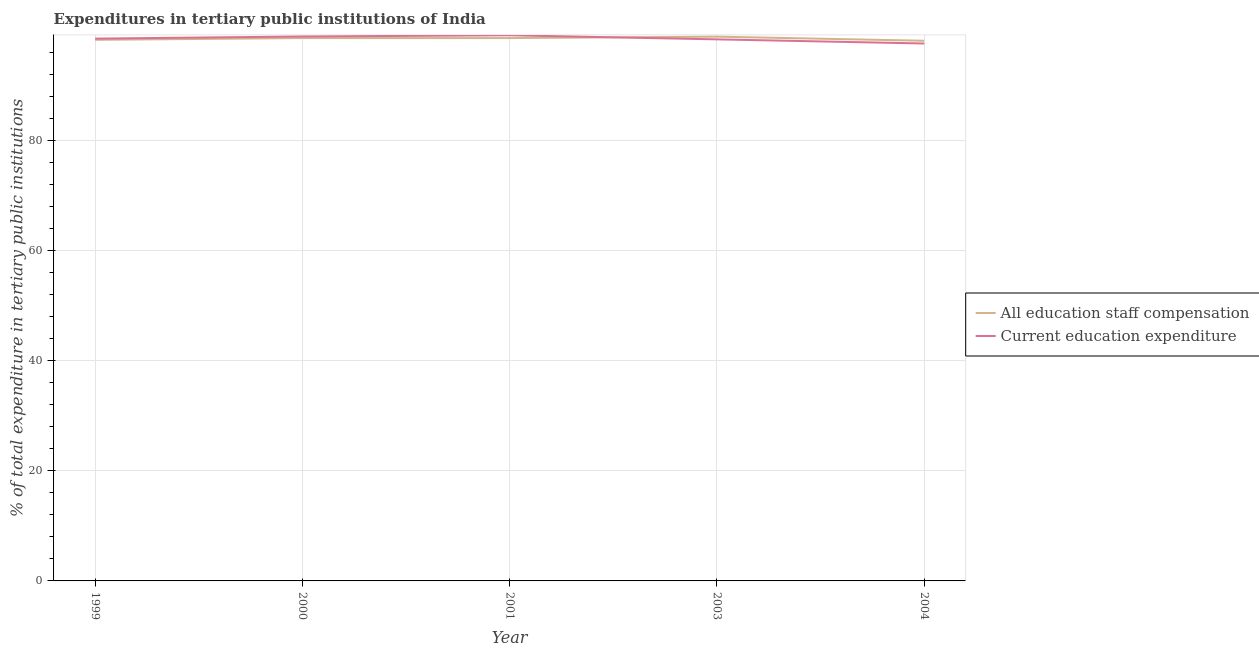Is the number of lines equal to the number of legend labels?
Offer a terse response. Yes. What is the expenditure in staff compensation in 1999?
Give a very brief answer. 98.21. Across all years, what is the maximum expenditure in staff compensation?
Provide a short and direct response. 98.79. Across all years, what is the minimum expenditure in education?
Give a very brief answer. 97.55. In which year was the expenditure in staff compensation maximum?
Provide a short and direct response. 2003. What is the total expenditure in education in the graph?
Make the answer very short. 492.13. What is the difference between the expenditure in staff compensation in 2001 and that in 2003?
Provide a short and direct response. -0.26. What is the difference between the expenditure in education in 1999 and the expenditure in staff compensation in 2003?
Offer a very short reply. -0.36. What is the average expenditure in staff compensation per year?
Give a very brief answer. 98.42. In the year 2004, what is the difference between the expenditure in education and expenditure in staff compensation?
Your response must be concise. -0.5. In how many years, is the expenditure in staff compensation greater than 40 %?
Offer a terse response. 5. What is the ratio of the expenditure in staff compensation in 1999 to that in 2001?
Keep it short and to the point. 1. Is the expenditure in education in 2003 less than that in 2004?
Keep it short and to the point. No. Is the difference between the expenditure in education in 1999 and 2004 greater than the difference between the expenditure in staff compensation in 1999 and 2004?
Keep it short and to the point. Yes. What is the difference between the highest and the second highest expenditure in staff compensation?
Provide a succinct answer. 0.26. What is the difference between the highest and the lowest expenditure in education?
Offer a terse response. 1.49. Does the expenditure in staff compensation monotonically increase over the years?
Make the answer very short. No. Is the expenditure in staff compensation strictly greater than the expenditure in education over the years?
Ensure brevity in your answer.  No. How many years are there in the graph?
Give a very brief answer. 5. What is the difference between two consecutive major ticks on the Y-axis?
Your answer should be compact. 20. Are the values on the major ticks of Y-axis written in scientific E-notation?
Your response must be concise. No. Does the graph contain any zero values?
Ensure brevity in your answer.  No. Does the graph contain grids?
Provide a short and direct response. Yes. Where does the legend appear in the graph?
Provide a succinct answer. Center right. How are the legend labels stacked?
Provide a succinct answer. Vertical. What is the title of the graph?
Your answer should be very brief. Expenditures in tertiary public institutions of India. What is the label or title of the X-axis?
Provide a short and direct response. Year. What is the label or title of the Y-axis?
Ensure brevity in your answer.  % of total expenditure in tertiary public institutions. What is the % of total expenditure in tertiary public institutions of All education staff compensation in 1999?
Provide a succinct answer. 98.21. What is the % of total expenditure in tertiary public institutions of Current education expenditure in 1999?
Provide a succinct answer. 98.43. What is the % of total expenditure in tertiary public institutions of All education staff compensation in 2000?
Provide a short and direct response. 98.53. What is the % of total expenditure in tertiary public institutions of Current education expenditure in 2000?
Make the answer very short. 98.82. What is the % of total expenditure in tertiary public institutions of All education staff compensation in 2001?
Your answer should be compact. 98.53. What is the % of total expenditure in tertiary public institutions of Current education expenditure in 2001?
Your response must be concise. 99.04. What is the % of total expenditure in tertiary public institutions of All education staff compensation in 2003?
Ensure brevity in your answer.  98.79. What is the % of total expenditure in tertiary public institutions in Current education expenditure in 2003?
Your answer should be very brief. 98.3. What is the % of total expenditure in tertiary public institutions of All education staff compensation in 2004?
Your response must be concise. 98.04. What is the % of total expenditure in tertiary public institutions of Current education expenditure in 2004?
Your answer should be compact. 97.55. Across all years, what is the maximum % of total expenditure in tertiary public institutions in All education staff compensation?
Offer a very short reply. 98.79. Across all years, what is the maximum % of total expenditure in tertiary public institutions of Current education expenditure?
Ensure brevity in your answer.  99.04. Across all years, what is the minimum % of total expenditure in tertiary public institutions in All education staff compensation?
Provide a succinct answer. 98.04. Across all years, what is the minimum % of total expenditure in tertiary public institutions of Current education expenditure?
Give a very brief answer. 97.55. What is the total % of total expenditure in tertiary public institutions of All education staff compensation in the graph?
Your response must be concise. 492.1. What is the total % of total expenditure in tertiary public institutions in Current education expenditure in the graph?
Keep it short and to the point. 492.13. What is the difference between the % of total expenditure in tertiary public institutions in All education staff compensation in 1999 and that in 2000?
Offer a very short reply. -0.32. What is the difference between the % of total expenditure in tertiary public institutions in Current education expenditure in 1999 and that in 2000?
Offer a very short reply. -0.39. What is the difference between the % of total expenditure in tertiary public institutions in All education staff compensation in 1999 and that in 2001?
Give a very brief answer. -0.32. What is the difference between the % of total expenditure in tertiary public institutions of Current education expenditure in 1999 and that in 2001?
Offer a terse response. -0.61. What is the difference between the % of total expenditure in tertiary public institutions in All education staff compensation in 1999 and that in 2003?
Offer a terse response. -0.58. What is the difference between the % of total expenditure in tertiary public institutions in Current education expenditure in 1999 and that in 2003?
Keep it short and to the point. 0.13. What is the difference between the % of total expenditure in tertiary public institutions in All education staff compensation in 1999 and that in 2004?
Offer a terse response. 0.17. What is the difference between the % of total expenditure in tertiary public institutions of Current education expenditure in 1999 and that in 2004?
Provide a short and direct response. 0.88. What is the difference between the % of total expenditure in tertiary public institutions of All education staff compensation in 2000 and that in 2001?
Keep it short and to the point. 0. What is the difference between the % of total expenditure in tertiary public institutions in Current education expenditure in 2000 and that in 2001?
Keep it short and to the point. -0.22. What is the difference between the % of total expenditure in tertiary public institutions of All education staff compensation in 2000 and that in 2003?
Your answer should be very brief. -0.26. What is the difference between the % of total expenditure in tertiary public institutions in Current education expenditure in 2000 and that in 2003?
Give a very brief answer. 0.52. What is the difference between the % of total expenditure in tertiary public institutions in All education staff compensation in 2000 and that in 2004?
Offer a terse response. 0.49. What is the difference between the % of total expenditure in tertiary public institutions in Current education expenditure in 2000 and that in 2004?
Your answer should be compact. 1.27. What is the difference between the % of total expenditure in tertiary public institutions of All education staff compensation in 2001 and that in 2003?
Offer a very short reply. -0.26. What is the difference between the % of total expenditure in tertiary public institutions of Current education expenditure in 2001 and that in 2003?
Offer a terse response. 0.74. What is the difference between the % of total expenditure in tertiary public institutions of All education staff compensation in 2001 and that in 2004?
Your answer should be compact. 0.49. What is the difference between the % of total expenditure in tertiary public institutions of Current education expenditure in 2001 and that in 2004?
Give a very brief answer. 1.49. What is the difference between the % of total expenditure in tertiary public institutions of All education staff compensation in 2003 and that in 2004?
Your response must be concise. 0.75. What is the difference between the % of total expenditure in tertiary public institutions of Current education expenditure in 2003 and that in 2004?
Offer a very short reply. 0.75. What is the difference between the % of total expenditure in tertiary public institutions of All education staff compensation in 1999 and the % of total expenditure in tertiary public institutions of Current education expenditure in 2000?
Your answer should be compact. -0.61. What is the difference between the % of total expenditure in tertiary public institutions in All education staff compensation in 1999 and the % of total expenditure in tertiary public institutions in Current education expenditure in 2001?
Give a very brief answer. -0.82. What is the difference between the % of total expenditure in tertiary public institutions in All education staff compensation in 1999 and the % of total expenditure in tertiary public institutions in Current education expenditure in 2003?
Your response must be concise. -0.08. What is the difference between the % of total expenditure in tertiary public institutions in All education staff compensation in 1999 and the % of total expenditure in tertiary public institutions in Current education expenditure in 2004?
Your answer should be very brief. 0.67. What is the difference between the % of total expenditure in tertiary public institutions in All education staff compensation in 2000 and the % of total expenditure in tertiary public institutions in Current education expenditure in 2001?
Your response must be concise. -0.51. What is the difference between the % of total expenditure in tertiary public institutions in All education staff compensation in 2000 and the % of total expenditure in tertiary public institutions in Current education expenditure in 2003?
Your response must be concise. 0.23. What is the difference between the % of total expenditure in tertiary public institutions of All education staff compensation in 2000 and the % of total expenditure in tertiary public institutions of Current education expenditure in 2004?
Your answer should be compact. 0.98. What is the difference between the % of total expenditure in tertiary public institutions in All education staff compensation in 2001 and the % of total expenditure in tertiary public institutions in Current education expenditure in 2003?
Provide a short and direct response. 0.23. What is the difference between the % of total expenditure in tertiary public institutions of All education staff compensation in 2001 and the % of total expenditure in tertiary public institutions of Current education expenditure in 2004?
Provide a short and direct response. 0.98. What is the difference between the % of total expenditure in tertiary public institutions of All education staff compensation in 2003 and the % of total expenditure in tertiary public institutions of Current education expenditure in 2004?
Your answer should be compact. 1.24. What is the average % of total expenditure in tertiary public institutions in All education staff compensation per year?
Ensure brevity in your answer.  98.42. What is the average % of total expenditure in tertiary public institutions of Current education expenditure per year?
Give a very brief answer. 98.43. In the year 1999, what is the difference between the % of total expenditure in tertiary public institutions of All education staff compensation and % of total expenditure in tertiary public institutions of Current education expenditure?
Offer a very short reply. -0.22. In the year 2000, what is the difference between the % of total expenditure in tertiary public institutions in All education staff compensation and % of total expenditure in tertiary public institutions in Current education expenditure?
Your answer should be compact. -0.29. In the year 2001, what is the difference between the % of total expenditure in tertiary public institutions in All education staff compensation and % of total expenditure in tertiary public institutions in Current education expenditure?
Provide a succinct answer. -0.51. In the year 2003, what is the difference between the % of total expenditure in tertiary public institutions in All education staff compensation and % of total expenditure in tertiary public institutions in Current education expenditure?
Your answer should be compact. 0.49. In the year 2004, what is the difference between the % of total expenditure in tertiary public institutions of All education staff compensation and % of total expenditure in tertiary public institutions of Current education expenditure?
Provide a succinct answer. 0.5. What is the ratio of the % of total expenditure in tertiary public institutions in Current education expenditure in 1999 to that in 2000?
Offer a terse response. 1. What is the ratio of the % of total expenditure in tertiary public institutions in All education staff compensation in 1999 to that in 2001?
Your response must be concise. 1. What is the ratio of the % of total expenditure in tertiary public institutions of Current education expenditure in 1999 to that in 2003?
Offer a very short reply. 1. What is the ratio of the % of total expenditure in tertiary public institutions in All education staff compensation in 1999 to that in 2004?
Ensure brevity in your answer.  1. What is the ratio of the % of total expenditure in tertiary public institutions of Current education expenditure in 1999 to that in 2004?
Make the answer very short. 1.01. What is the ratio of the % of total expenditure in tertiary public institutions of All education staff compensation in 2000 to that in 2001?
Ensure brevity in your answer.  1. What is the ratio of the % of total expenditure in tertiary public institutions of Current education expenditure in 2000 to that in 2001?
Your answer should be compact. 1. What is the ratio of the % of total expenditure in tertiary public institutions of All education staff compensation in 2000 to that in 2003?
Provide a succinct answer. 1. What is the ratio of the % of total expenditure in tertiary public institutions in All education staff compensation in 2000 to that in 2004?
Provide a short and direct response. 1. What is the ratio of the % of total expenditure in tertiary public institutions of Current education expenditure in 2000 to that in 2004?
Provide a succinct answer. 1.01. What is the ratio of the % of total expenditure in tertiary public institutions in Current education expenditure in 2001 to that in 2003?
Your answer should be compact. 1.01. What is the ratio of the % of total expenditure in tertiary public institutions in Current education expenditure in 2001 to that in 2004?
Provide a succinct answer. 1.02. What is the ratio of the % of total expenditure in tertiary public institutions in All education staff compensation in 2003 to that in 2004?
Your answer should be compact. 1.01. What is the ratio of the % of total expenditure in tertiary public institutions of Current education expenditure in 2003 to that in 2004?
Keep it short and to the point. 1.01. What is the difference between the highest and the second highest % of total expenditure in tertiary public institutions in All education staff compensation?
Offer a terse response. 0.26. What is the difference between the highest and the second highest % of total expenditure in tertiary public institutions of Current education expenditure?
Offer a very short reply. 0.22. What is the difference between the highest and the lowest % of total expenditure in tertiary public institutions in All education staff compensation?
Provide a succinct answer. 0.75. What is the difference between the highest and the lowest % of total expenditure in tertiary public institutions in Current education expenditure?
Keep it short and to the point. 1.49. 